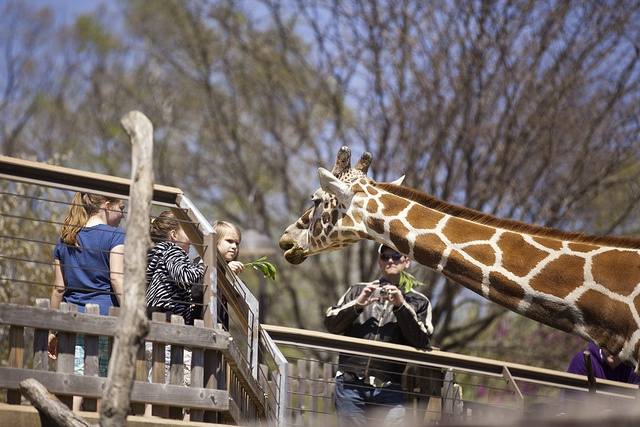Describe the objects in this image and their specific colors. I can see giraffe in gray, maroon, brown, and black tones, people in gray, black, darkgray, and ivory tones, people in gray, blue, black, and navy tones, people in gray, black, darkgray, and lightgray tones, and people in gray, black, navy, and purple tones in this image. 